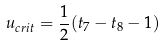Convert formula to latex. <formula><loc_0><loc_0><loc_500><loc_500>u _ { c r i t } = { \frac { 1 } { 2 } } ( t _ { 7 } - t _ { 8 } - 1 )</formula> 